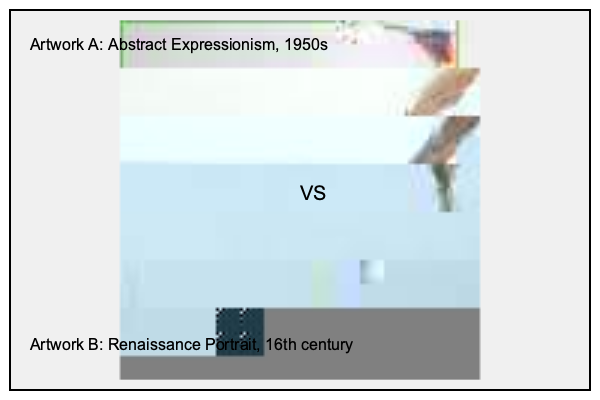Based on the visual characteristics and historical context of the two artworks shown, which one is likely to have a higher market value in today's art market? To determine the relative market value of these two artworks, we need to consider several factors:

1. Historical significance:
   - Artwork A: Abstract Expressionism from the 1950s, a significant modern art movement.
   - Artwork B: Renaissance portrait from the 16th century, representing a highly valued historical period.

2. Rarity:
   - Artwork A: While important, there are more Abstract Expressionist works available.
   - Artwork B: Renaissance paintings are much rarer due to their age and historical importance.

3. Artist reputation:
   - Without specific artist information, we assume both are by notable artists of their respective periods.

4. Market trends:
   - Both periods are highly valued, but Renaissance works typically command higher prices due to rarity and historical significance.

5. Condition:
   - Assuming both are in good condition for their respective ages.

6. Size and medium:
   - Both appear to be paintings of similar size.

7. Provenance:
   - Unknown for both, but Renaissance works often have more documented history.

8. Cultural and academic interest:
   - Both periods are extensively studied, but Renaissance works often have broader appeal.

Given these factors, Artwork B (the Renaissance portrait) is likely to have a higher market value. Renaissance masterpieces are extremely rare and highly sought after by collectors and museums. They often set record prices at auctions due to their historical significance, rarity, and broad appeal.

While Abstract Expressionist works can also command high prices, they are generally more abundant in the market and typically don't reach the extreme values of Renaissance masterpieces.
Answer: Artwork B (Renaissance portrait) 